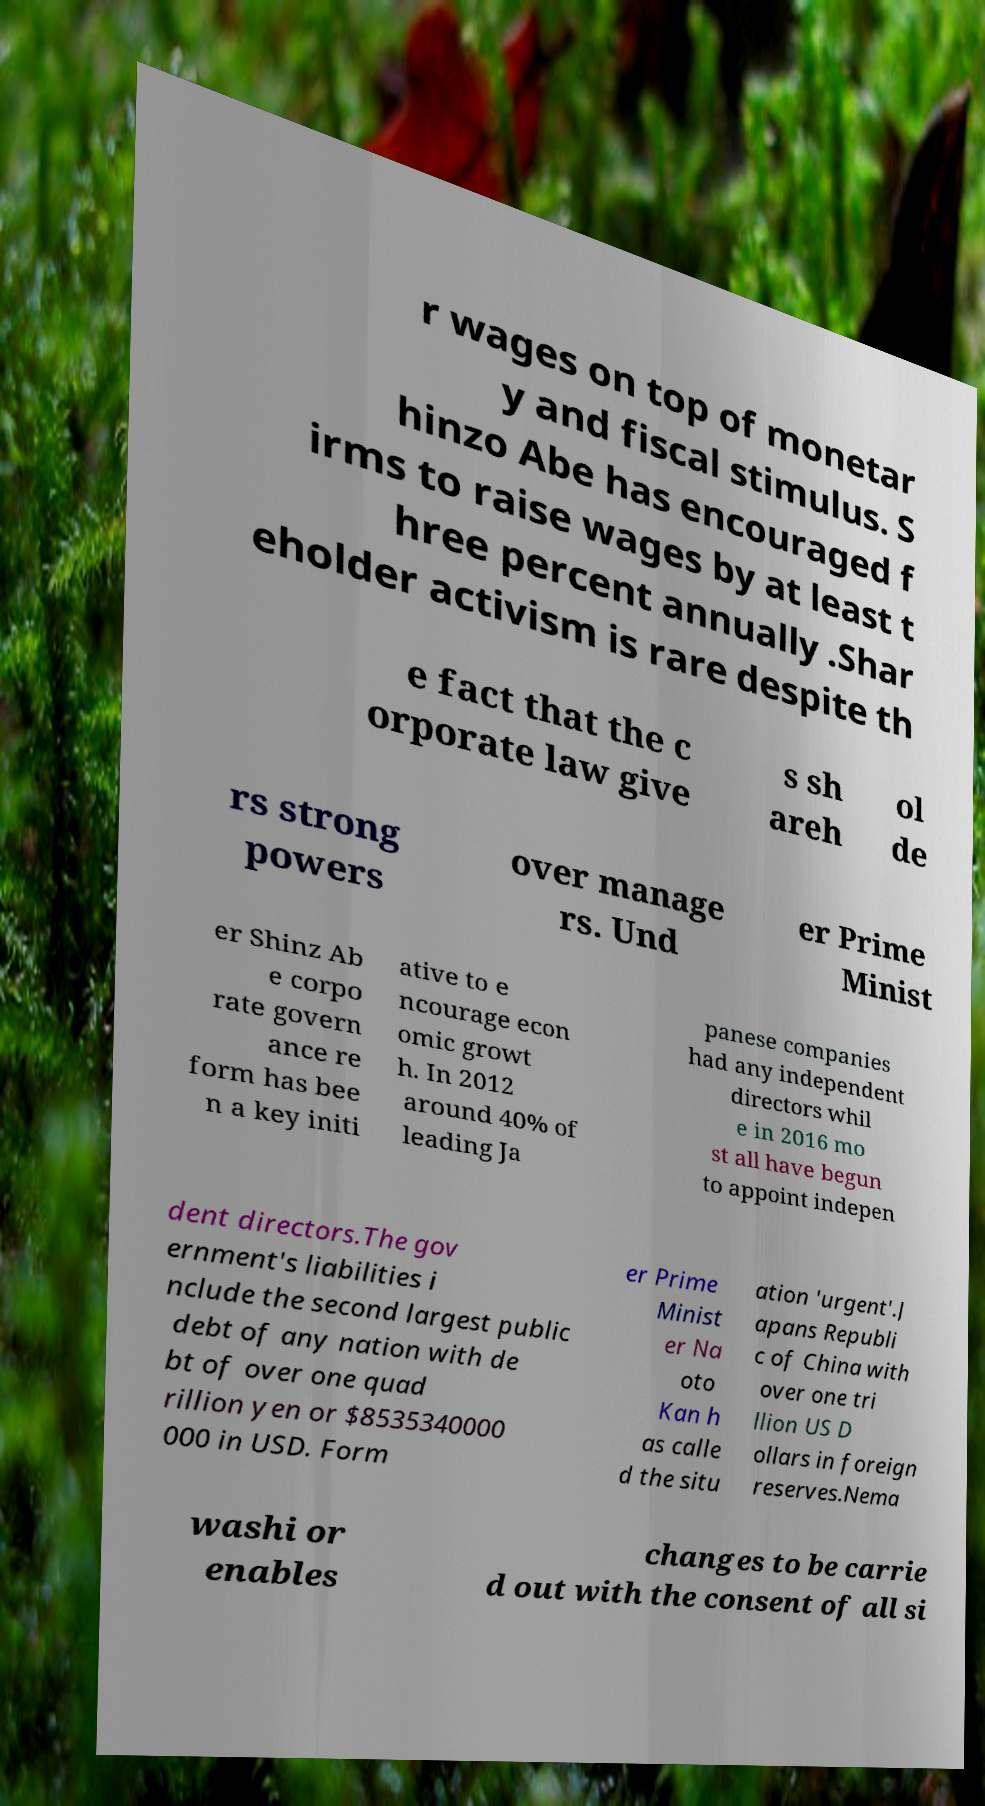Could you assist in decoding the text presented in this image and type it out clearly? r wages on top of monetar y and fiscal stimulus. S hinzo Abe has encouraged f irms to raise wages by at least t hree percent annually .Shar eholder activism is rare despite th e fact that the c orporate law give s sh areh ol de rs strong powers over manage rs. Und er Prime Minist er Shinz Ab e corpo rate govern ance re form has bee n a key initi ative to e ncourage econ omic growt h. In 2012 around 40% of leading Ja panese companies had any independent directors whil e in 2016 mo st all have begun to appoint indepen dent directors.The gov ernment's liabilities i nclude the second largest public debt of any nation with de bt of over one quad rillion yen or $8535340000 000 in USD. Form er Prime Minist er Na oto Kan h as calle d the situ ation 'urgent'.J apans Republi c of China with over one tri llion US D ollars in foreign reserves.Nema washi or enables changes to be carrie d out with the consent of all si 